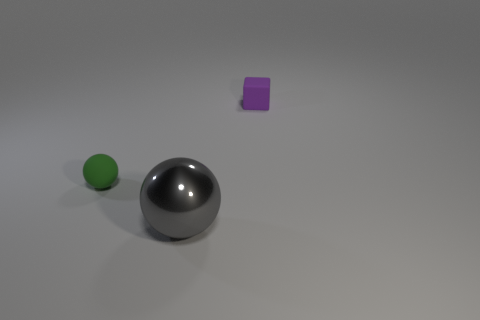How many other green things are the same size as the green object?
Your answer should be compact. 0. What is the shape of the small purple thing that is the same material as the green ball?
Keep it short and to the point. Cube. What material is the small green ball?
Offer a terse response. Rubber. How many things are large shiny objects or tiny things?
Make the answer very short. 3. How big is the matte thing right of the small green object?
Give a very brief answer. Small. How many other objects are the same material as the large ball?
Your answer should be very brief. 0. Are there any tiny green balls in front of the object that is behind the tiny green sphere?
Provide a succinct answer. Yes. Are there any other things that have the same shape as the purple matte thing?
Your answer should be compact. No. There is another object that is the same shape as the gray thing; what is its color?
Provide a short and direct response. Green. What is the size of the gray metallic sphere?
Make the answer very short. Large. 